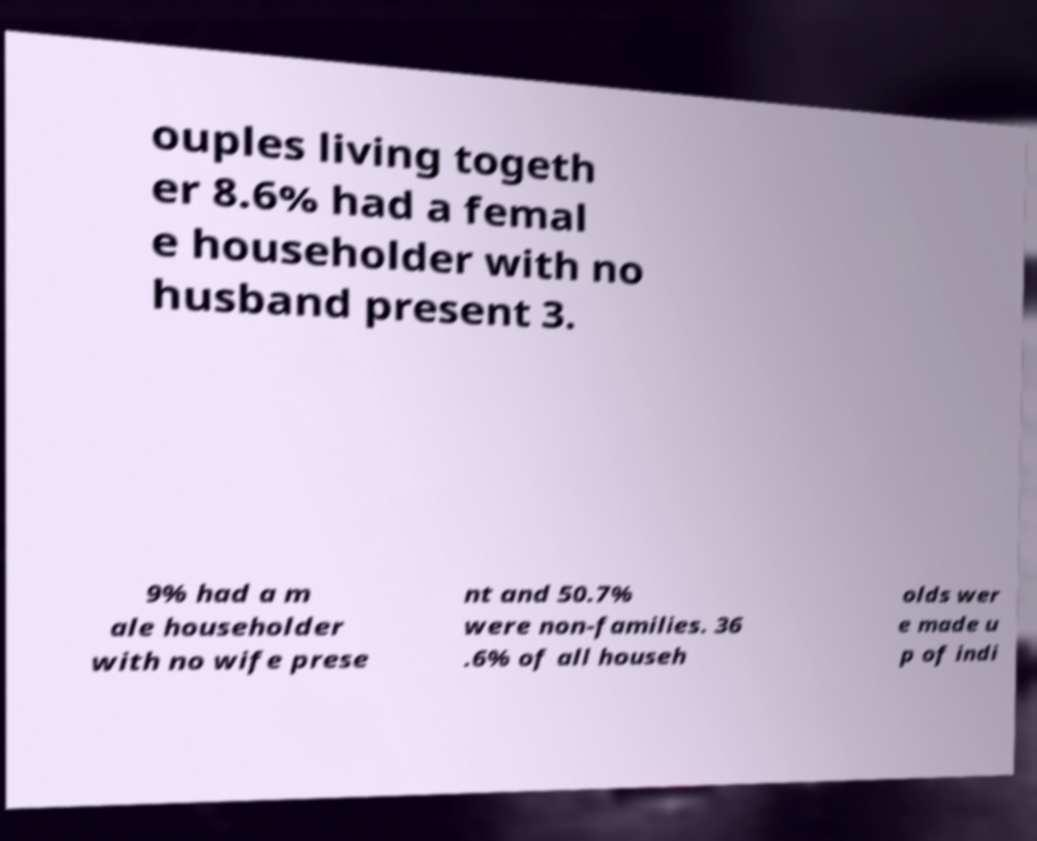Please read and relay the text visible in this image. What does it say? ouples living togeth er 8.6% had a femal e householder with no husband present 3. 9% had a m ale householder with no wife prese nt and 50.7% were non-families. 36 .6% of all househ olds wer e made u p of indi 